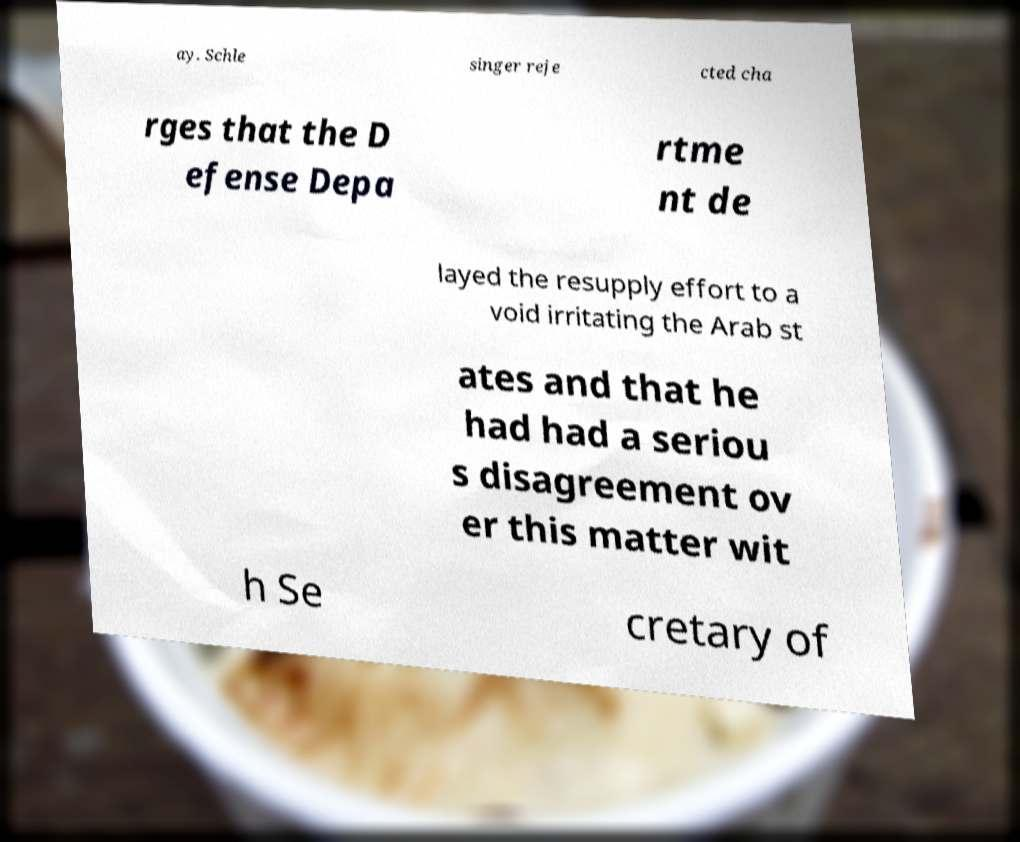Please read and relay the text visible in this image. What does it say? ay. Schle singer reje cted cha rges that the D efense Depa rtme nt de layed the resupply effort to a void irritating the Arab st ates and that he had had a seriou s disagreement ov er this matter wit h Se cretary of 